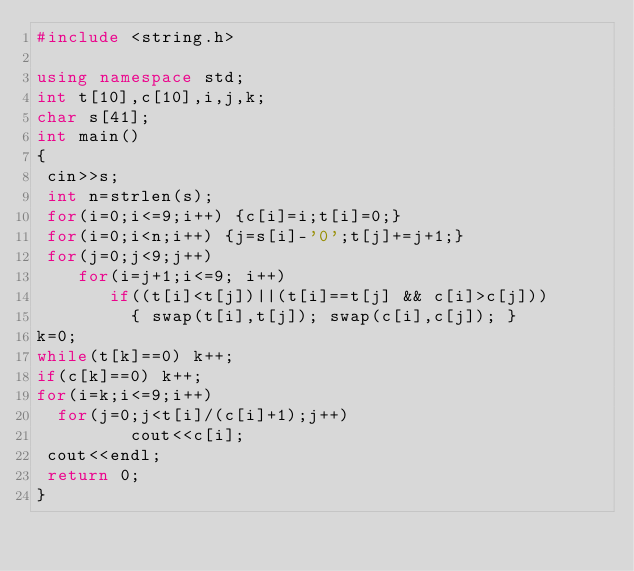<code> <loc_0><loc_0><loc_500><loc_500><_C++_>#include <string.h>

using namespace std;
int t[10],c[10],i,j,k;
char s[41];
int main()
{
 cin>>s;
 int n=strlen(s);
 for(i=0;i<=9;i++) {c[i]=i;t[i]=0;}
 for(i=0;i<n;i++) {j=s[i]-'0';t[j]+=j+1;}
 for(j=0;j<9;j++)
    for(i=j+1;i<=9; i++)
       if((t[i]<t[j])||(t[i]==t[j] && c[i]>c[j]))
         { swap(t[i],t[j]); swap(c[i],c[j]); }
k=0;
while(t[k]==0) k++;
if(c[k]==0) k++;
for(i=k;i<=9;i++)
  for(j=0;j<t[i]/(c[i]+1);j++)
         cout<<c[i];
 cout<<endl;
 return 0;
}

</code> 